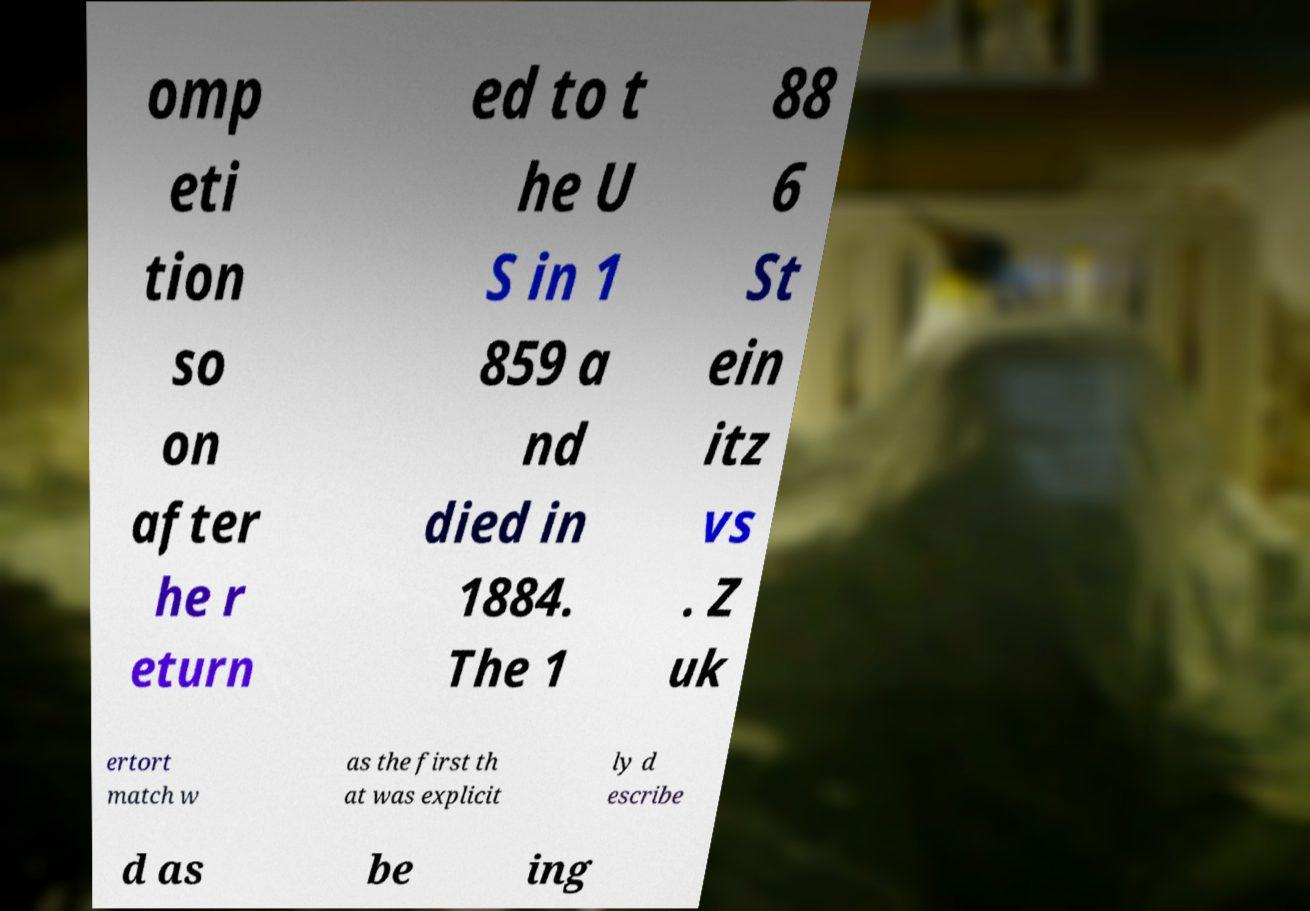Can you accurately transcribe the text from the provided image for me? omp eti tion so on after he r eturn ed to t he U S in 1 859 a nd died in 1884. The 1 88 6 St ein itz vs . Z uk ertort match w as the first th at was explicit ly d escribe d as be ing 